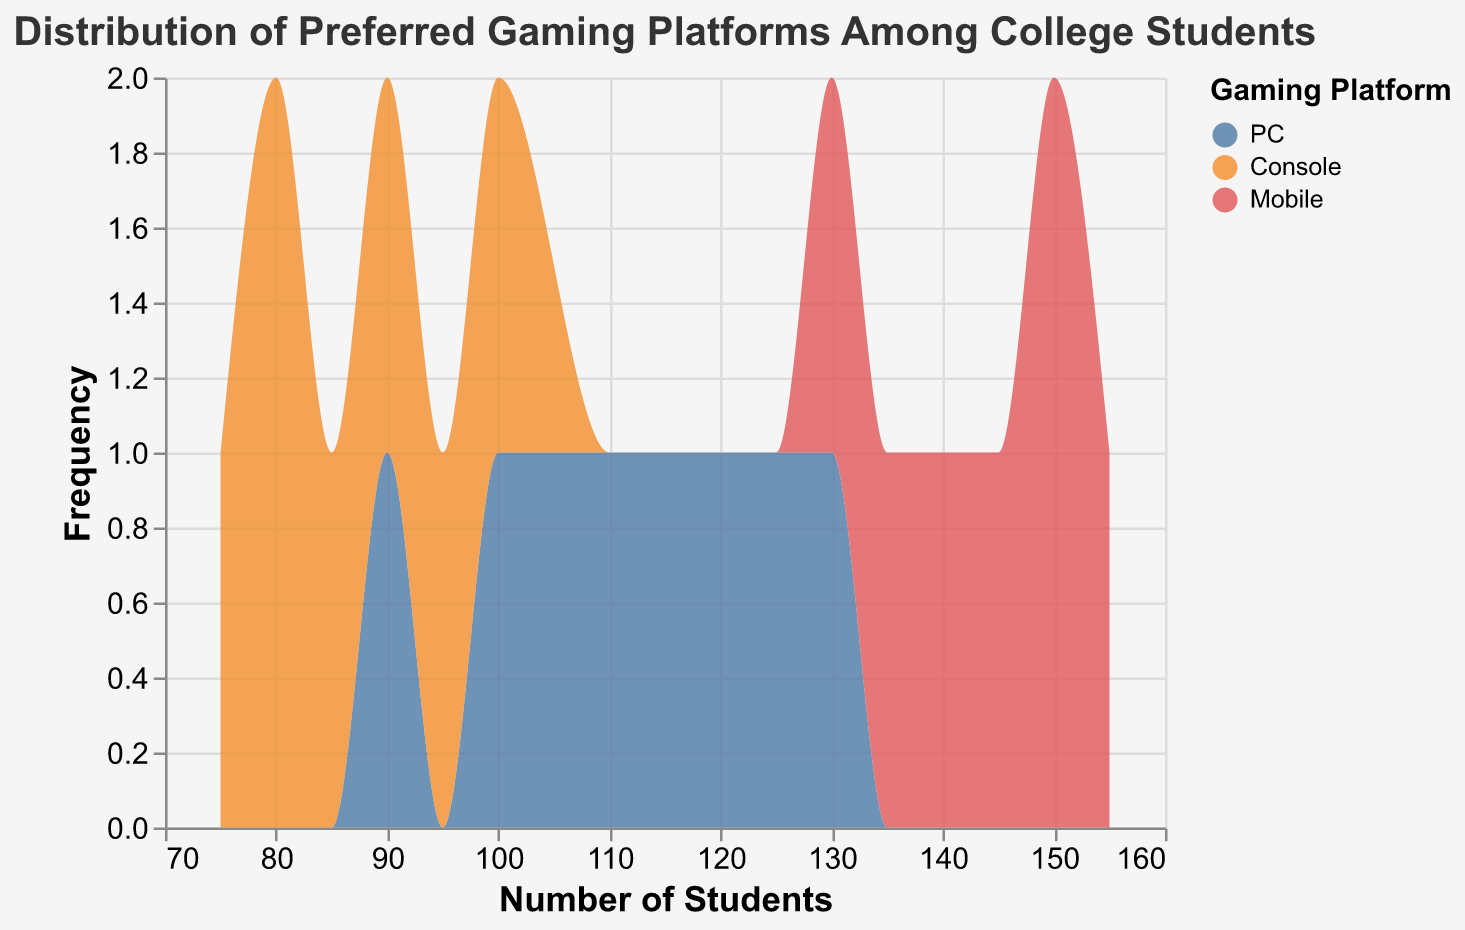What's the title of the figure? The title is displayed at the top of the figure, written in a larger font size and bolded, summarizing what the graph is about.
Answer: Distribution of Preferred Gaming Platforms Among College Students How many different gaming platforms are depicted in the figure? There are three distinct colors in the figure's legend, each representing a gaming platform. These are PC, Console, and Mobile.
Answer: Three What's the color used to represent the "Mobile" gaming platform? The legend on the right side of the figure indicates the color associated with each gaming platform. The color corresponding to "Mobile" is red.
Answer: Red Which gaming platform has the highest individual number of students represented in the data? From the data values shown in the figure, the maximum number of students for each platform is checked. The highest individual number observed is 155 for Mobile.
Answer: Mobile What's the range of the number of students for the "Console" platform? By observing the frequency plot for the Console platform, look for the minimum and maximum values on the x-axis, which range from 75 to 100.
Answer: 75 to 100 What's the total number of unique data points represented in the figure? Each platform has the same number of data points. By counting “Number of Students” for any platform (such as PC), we see 7 data points. Multiply by the 3 platforms gives a total.
Answer: 21 What is the most frequent number of students for the "PC" platform? The peak of the area plot for PC in blue shows the most occurrences. The highest point aligns with around 115 students.
Answer: 115 Which platform shows the widest distribution in terms of student numbers? The width of the distribution for each platform is observed on the x-axis. Mobile, represented in red, spans the broadest range, implying the widest distribution.
Answer: Mobile What is the sum of the lower and upper bounds for the "Mobile" platform? Identify the lowest and highest numbers of students for Mobile (130 and 155 respectively) and sum them. 130 + 155 = 285
Answer: 285 Which platform has the smallest variation in student numbers? By comparing the spread of each plot, the Console platform has the smallest range, resulting in less variation.
Answer: Console 